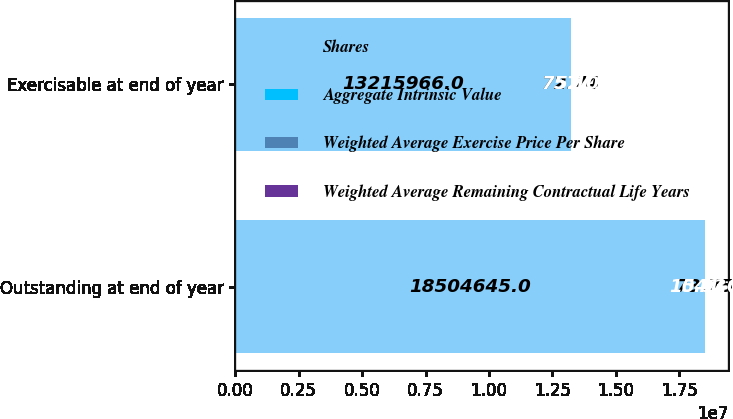<chart> <loc_0><loc_0><loc_500><loc_500><stacked_bar_chart><ecel><fcel>Outstanding at end of year<fcel>Exercisable at end of year<nl><fcel>Shares<fcel>1.85046e+07<fcel>1.3216e+07<nl><fcel>Aggregate Intrinsic Value<fcel>73.75<fcel>72.74<nl><fcel>Weighted Average Exercise Price Per Share<fcel>5.93<fcel>5.1<nl><fcel>Weighted Average Remaining Contractual Life Years<fcel>1041<fcel>757<nl></chart> 